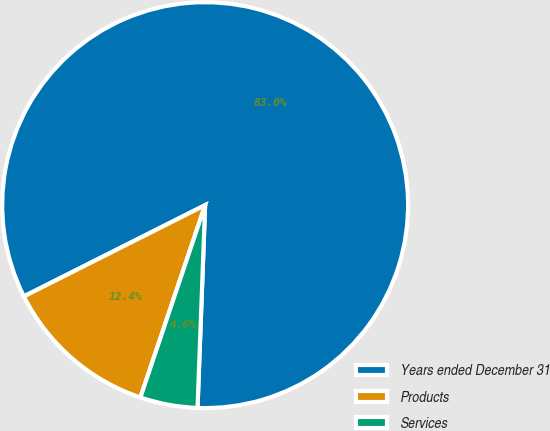Convert chart to OTSL. <chart><loc_0><loc_0><loc_500><loc_500><pie_chart><fcel>Years ended December 31<fcel>Products<fcel>Services<nl><fcel>83.02%<fcel>12.41%<fcel>4.57%<nl></chart> 